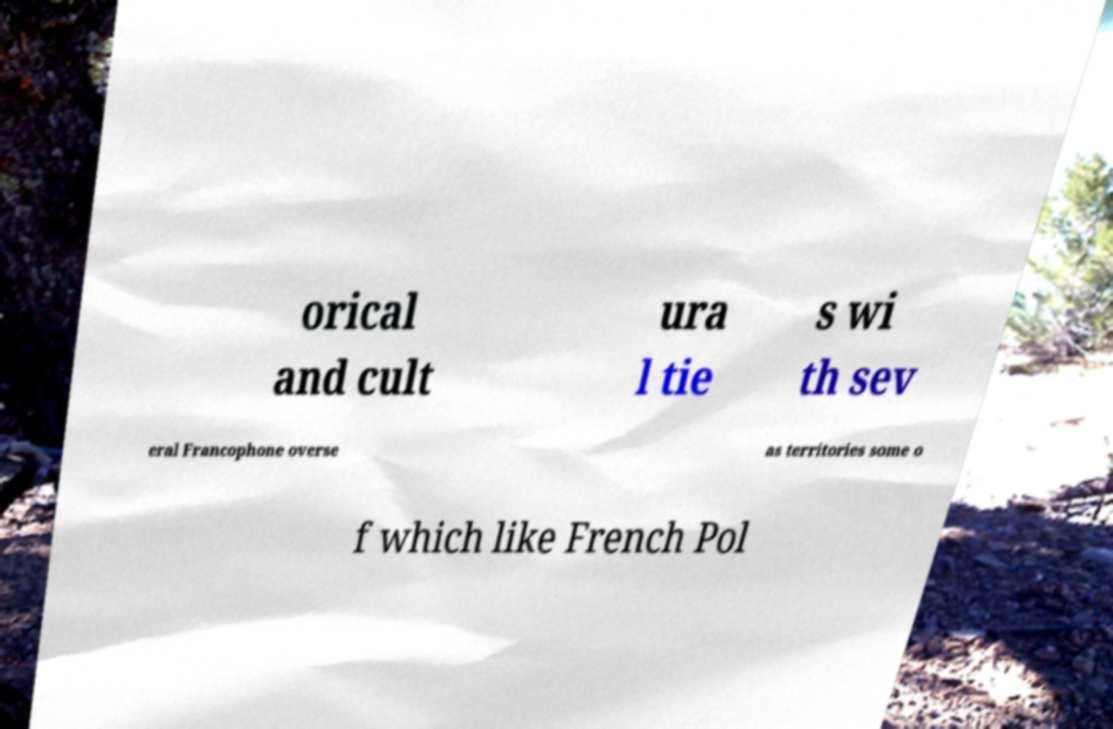I need the written content from this picture converted into text. Can you do that? orical and cult ura l tie s wi th sev eral Francophone overse as territories some o f which like French Pol 